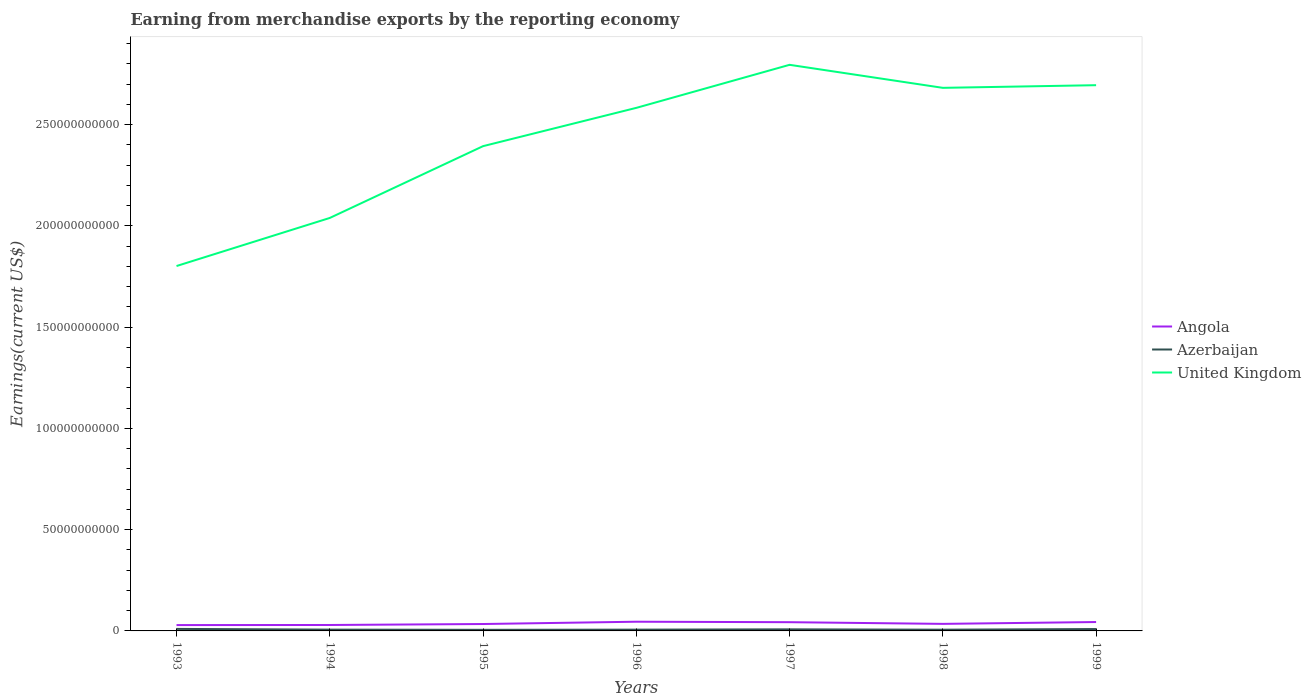Does the line corresponding to Angola intersect with the line corresponding to United Kingdom?
Offer a terse response. No. Is the number of lines equal to the number of legend labels?
Offer a terse response. Yes. Across all years, what is the maximum amount earned from merchandise exports in United Kingdom?
Your response must be concise. 1.80e+11. What is the total amount earned from merchandise exports in Angola in the graph?
Your response must be concise. 2.34e+08. What is the difference between the highest and the second highest amount earned from merchandise exports in Azerbaijan?
Keep it short and to the point. 4.46e+08. What is the difference between the highest and the lowest amount earned from merchandise exports in Angola?
Offer a very short reply. 3. Is the amount earned from merchandise exports in Azerbaijan strictly greater than the amount earned from merchandise exports in United Kingdom over the years?
Give a very brief answer. Yes. How many lines are there?
Your answer should be compact. 3. How many years are there in the graph?
Give a very brief answer. 7. What is the difference between two consecutive major ticks on the Y-axis?
Give a very brief answer. 5.00e+1. Are the values on the major ticks of Y-axis written in scientific E-notation?
Your answer should be compact. No. Does the graph contain any zero values?
Provide a succinct answer. No. How many legend labels are there?
Provide a short and direct response. 3. What is the title of the graph?
Give a very brief answer. Earning from merchandise exports by the reporting economy. Does "Small states" appear as one of the legend labels in the graph?
Give a very brief answer. No. What is the label or title of the Y-axis?
Provide a short and direct response. Earnings(current US$). What is the Earnings(current US$) in Angola in 1993?
Offer a very short reply. 2.88e+09. What is the Earnings(current US$) in Azerbaijan in 1993?
Give a very brief answer. 9.93e+08. What is the Earnings(current US$) in United Kingdom in 1993?
Make the answer very short. 1.80e+11. What is the Earnings(current US$) in Angola in 1994?
Keep it short and to the point. 2.93e+09. What is the Earnings(current US$) in Azerbaijan in 1994?
Your answer should be compact. 6.37e+08. What is the Earnings(current US$) of United Kingdom in 1994?
Offer a terse response. 2.04e+11. What is the Earnings(current US$) in Angola in 1995?
Your answer should be very brief. 3.41e+09. What is the Earnings(current US$) in Azerbaijan in 1995?
Your answer should be very brief. 5.47e+08. What is the Earnings(current US$) in United Kingdom in 1995?
Keep it short and to the point. 2.39e+11. What is the Earnings(current US$) of Angola in 1996?
Offer a very short reply. 4.54e+09. What is the Earnings(current US$) in Azerbaijan in 1996?
Your response must be concise. 6.31e+08. What is the Earnings(current US$) in United Kingdom in 1996?
Provide a short and direct response. 2.58e+11. What is the Earnings(current US$) in Angola in 1997?
Your answer should be compact. 4.31e+09. What is the Earnings(current US$) of Azerbaijan in 1997?
Provide a short and direct response. 7.81e+08. What is the Earnings(current US$) of United Kingdom in 1997?
Your answer should be compact. 2.80e+11. What is the Earnings(current US$) in Angola in 1998?
Offer a very short reply. 3.48e+09. What is the Earnings(current US$) in Azerbaijan in 1998?
Your answer should be very brief. 6.07e+08. What is the Earnings(current US$) of United Kingdom in 1998?
Your answer should be very brief. 2.68e+11. What is the Earnings(current US$) of Angola in 1999?
Provide a succinct answer. 4.39e+09. What is the Earnings(current US$) in Azerbaijan in 1999?
Your response must be concise. 9.29e+08. What is the Earnings(current US$) of United Kingdom in 1999?
Your answer should be compact. 2.69e+11. Across all years, what is the maximum Earnings(current US$) of Angola?
Give a very brief answer. 4.54e+09. Across all years, what is the maximum Earnings(current US$) of Azerbaijan?
Provide a succinct answer. 9.93e+08. Across all years, what is the maximum Earnings(current US$) of United Kingdom?
Your answer should be very brief. 2.80e+11. Across all years, what is the minimum Earnings(current US$) in Angola?
Give a very brief answer. 2.88e+09. Across all years, what is the minimum Earnings(current US$) of Azerbaijan?
Offer a very short reply. 5.47e+08. Across all years, what is the minimum Earnings(current US$) of United Kingdom?
Provide a short and direct response. 1.80e+11. What is the total Earnings(current US$) of Angola in the graph?
Your response must be concise. 2.60e+1. What is the total Earnings(current US$) of Azerbaijan in the graph?
Your answer should be very brief. 5.13e+09. What is the total Earnings(current US$) of United Kingdom in the graph?
Your answer should be compact. 1.70e+12. What is the difference between the Earnings(current US$) in Angola in 1993 and that in 1994?
Provide a short and direct response. -5.01e+07. What is the difference between the Earnings(current US$) in Azerbaijan in 1993 and that in 1994?
Keep it short and to the point. 3.56e+08. What is the difference between the Earnings(current US$) of United Kingdom in 1993 and that in 1994?
Provide a succinct answer. -2.37e+1. What is the difference between the Earnings(current US$) in Angola in 1993 and that in 1995?
Ensure brevity in your answer.  -5.28e+08. What is the difference between the Earnings(current US$) of Azerbaijan in 1993 and that in 1995?
Your response must be concise. 4.46e+08. What is the difference between the Earnings(current US$) of United Kingdom in 1993 and that in 1995?
Provide a short and direct response. -5.92e+1. What is the difference between the Earnings(current US$) in Angola in 1993 and that in 1996?
Make the answer very short. -1.66e+09. What is the difference between the Earnings(current US$) of Azerbaijan in 1993 and that in 1996?
Offer a terse response. 3.62e+08. What is the difference between the Earnings(current US$) in United Kingdom in 1993 and that in 1996?
Give a very brief answer. -7.81e+1. What is the difference between the Earnings(current US$) of Angola in 1993 and that in 1997?
Make the answer very short. -1.43e+09. What is the difference between the Earnings(current US$) in Azerbaijan in 1993 and that in 1997?
Ensure brevity in your answer.  2.12e+08. What is the difference between the Earnings(current US$) of United Kingdom in 1993 and that in 1997?
Your answer should be very brief. -9.94e+1. What is the difference between the Earnings(current US$) in Angola in 1993 and that in 1998?
Offer a very short reply. -5.94e+08. What is the difference between the Earnings(current US$) of Azerbaijan in 1993 and that in 1998?
Your answer should be very brief. 3.86e+08. What is the difference between the Earnings(current US$) in United Kingdom in 1993 and that in 1998?
Your answer should be very brief. -8.80e+1. What is the difference between the Earnings(current US$) in Angola in 1993 and that in 1999?
Make the answer very short. -1.51e+09. What is the difference between the Earnings(current US$) in Azerbaijan in 1993 and that in 1999?
Ensure brevity in your answer.  6.39e+07. What is the difference between the Earnings(current US$) of United Kingdom in 1993 and that in 1999?
Your answer should be very brief. -8.93e+1. What is the difference between the Earnings(current US$) in Angola in 1994 and that in 1995?
Ensure brevity in your answer.  -4.78e+08. What is the difference between the Earnings(current US$) of Azerbaijan in 1994 and that in 1995?
Provide a succinct answer. 9.03e+07. What is the difference between the Earnings(current US$) of United Kingdom in 1994 and that in 1995?
Your answer should be compact. -3.55e+1. What is the difference between the Earnings(current US$) of Angola in 1994 and that in 1996?
Offer a very short reply. -1.61e+09. What is the difference between the Earnings(current US$) in Azerbaijan in 1994 and that in 1996?
Your answer should be very brief. 6.21e+06. What is the difference between the Earnings(current US$) of United Kingdom in 1994 and that in 1996?
Keep it short and to the point. -5.44e+1. What is the difference between the Earnings(current US$) of Angola in 1994 and that in 1997?
Your answer should be compact. -1.38e+09. What is the difference between the Earnings(current US$) in Azerbaijan in 1994 and that in 1997?
Keep it short and to the point. -1.44e+08. What is the difference between the Earnings(current US$) of United Kingdom in 1994 and that in 1997?
Provide a succinct answer. -7.56e+1. What is the difference between the Earnings(current US$) in Angola in 1994 and that in 1998?
Ensure brevity in your answer.  -5.44e+08. What is the difference between the Earnings(current US$) in Azerbaijan in 1994 and that in 1998?
Offer a very short reply. 3.04e+07. What is the difference between the Earnings(current US$) of United Kingdom in 1994 and that in 1998?
Keep it short and to the point. -6.42e+1. What is the difference between the Earnings(current US$) of Angola in 1994 and that in 1999?
Ensure brevity in your answer.  -1.46e+09. What is the difference between the Earnings(current US$) of Azerbaijan in 1994 and that in 1999?
Offer a very short reply. -2.92e+08. What is the difference between the Earnings(current US$) in United Kingdom in 1994 and that in 1999?
Your response must be concise. -6.56e+1. What is the difference between the Earnings(current US$) of Angola in 1995 and that in 1996?
Give a very brief answer. -1.13e+09. What is the difference between the Earnings(current US$) of Azerbaijan in 1995 and that in 1996?
Ensure brevity in your answer.  -8.41e+07. What is the difference between the Earnings(current US$) in United Kingdom in 1995 and that in 1996?
Ensure brevity in your answer.  -1.89e+1. What is the difference between the Earnings(current US$) of Angola in 1995 and that in 1997?
Make the answer very short. -8.99e+08. What is the difference between the Earnings(current US$) in Azerbaijan in 1995 and that in 1997?
Offer a very short reply. -2.34e+08. What is the difference between the Earnings(current US$) of United Kingdom in 1995 and that in 1997?
Your answer should be very brief. -4.02e+1. What is the difference between the Earnings(current US$) in Angola in 1995 and that in 1998?
Offer a terse response. -6.57e+07. What is the difference between the Earnings(current US$) of Azerbaijan in 1995 and that in 1998?
Make the answer very short. -5.99e+07. What is the difference between the Earnings(current US$) in United Kingdom in 1995 and that in 1998?
Make the answer very short. -2.88e+1. What is the difference between the Earnings(current US$) in Angola in 1995 and that in 1999?
Give a very brief answer. -9.82e+08. What is the difference between the Earnings(current US$) in Azerbaijan in 1995 and that in 1999?
Offer a very short reply. -3.82e+08. What is the difference between the Earnings(current US$) of United Kingdom in 1995 and that in 1999?
Offer a terse response. -3.01e+1. What is the difference between the Earnings(current US$) in Angola in 1996 and that in 1997?
Keep it short and to the point. 2.34e+08. What is the difference between the Earnings(current US$) of Azerbaijan in 1996 and that in 1997?
Your answer should be compact. -1.50e+08. What is the difference between the Earnings(current US$) of United Kingdom in 1996 and that in 1997?
Offer a very short reply. -2.13e+1. What is the difference between the Earnings(current US$) of Angola in 1996 and that in 1998?
Make the answer very short. 1.07e+09. What is the difference between the Earnings(current US$) in Azerbaijan in 1996 and that in 1998?
Provide a succinct answer. 2.42e+07. What is the difference between the Earnings(current US$) in United Kingdom in 1996 and that in 1998?
Make the answer very short. -9.88e+09. What is the difference between the Earnings(current US$) of Angola in 1996 and that in 1999?
Keep it short and to the point. 1.50e+08. What is the difference between the Earnings(current US$) of Azerbaijan in 1996 and that in 1999?
Give a very brief answer. -2.98e+08. What is the difference between the Earnings(current US$) of United Kingdom in 1996 and that in 1999?
Offer a terse response. -1.12e+1. What is the difference between the Earnings(current US$) in Angola in 1997 and that in 1998?
Your answer should be very brief. 8.33e+08. What is the difference between the Earnings(current US$) in Azerbaijan in 1997 and that in 1998?
Keep it short and to the point. 1.74e+08. What is the difference between the Earnings(current US$) in United Kingdom in 1997 and that in 1998?
Your answer should be very brief. 1.14e+1. What is the difference between the Earnings(current US$) in Angola in 1997 and that in 1999?
Make the answer very short. -8.33e+07. What is the difference between the Earnings(current US$) in Azerbaijan in 1997 and that in 1999?
Give a very brief answer. -1.48e+08. What is the difference between the Earnings(current US$) in United Kingdom in 1997 and that in 1999?
Make the answer very short. 1.01e+1. What is the difference between the Earnings(current US$) of Angola in 1998 and that in 1999?
Provide a short and direct response. -9.16e+08. What is the difference between the Earnings(current US$) in Azerbaijan in 1998 and that in 1999?
Make the answer very short. -3.22e+08. What is the difference between the Earnings(current US$) in United Kingdom in 1998 and that in 1999?
Offer a very short reply. -1.31e+09. What is the difference between the Earnings(current US$) in Angola in 1993 and the Earnings(current US$) in Azerbaijan in 1994?
Ensure brevity in your answer.  2.25e+09. What is the difference between the Earnings(current US$) in Angola in 1993 and the Earnings(current US$) in United Kingdom in 1994?
Make the answer very short. -2.01e+11. What is the difference between the Earnings(current US$) in Azerbaijan in 1993 and the Earnings(current US$) in United Kingdom in 1994?
Offer a very short reply. -2.03e+11. What is the difference between the Earnings(current US$) in Angola in 1993 and the Earnings(current US$) in Azerbaijan in 1995?
Keep it short and to the point. 2.34e+09. What is the difference between the Earnings(current US$) in Angola in 1993 and the Earnings(current US$) in United Kingdom in 1995?
Provide a succinct answer. -2.37e+11. What is the difference between the Earnings(current US$) in Azerbaijan in 1993 and the Earnings(current US$) in United Kingdom in 1995?
Your response must be concise. -2.38e+11. What is the difference between the Earnings(current US$) of Angola in 1993 and the Earnings(current US$) of Azerbaijan in 1996?
Your response must be concise. 2.25e+09. What is the difference between the Earnings(current US$) of Angola in 1993 and the Earnings(current US$) of United Kingdom in 1996?
Keep it short and to the point. -2.55e+11. What is the difference between the Earnings(current US$) of Azerbaijan in 1993 and the Earnings(current US$) of United Kingdom in 1996?
Ensure brevity in your answer.  -2.57e+11. What is the difference between the Earnings(current US$) of Angola in 1993 and the Earnings(current US$) of Azerbaijan in 1997?
Provide a succinct answer. 2.10e+09. What is the difference between the Earnings(current US$) in Angola in 1993 and the Earnings(current US$) in United Kingdom in 1997?
Give a very brief answer. -2.77e+11. What is the difference between the Earnings(current US$) of Azerbaijan in 1993 and the Earnings(current US$) of United Kingdom in 1997?
Keep it short and to the point. -2.79e+11. What is the difference between the Earnings(current US$) in Angola in 1993 and the Earnings(current US$) in Azerbaijan in 1998?
Make the answer very short. 2.28e+09. What is the difference between the Earnings(current US$) in Angola in 1993 and the Earnings(current US$) in United Kingdom in 1998?
Offer a terse response. -2.65e+11. What is the difference between the Earnings(current US$) in Azerbaijan in 1993 and the Earnings(current US$) in United Kingdom in 1998?
Your answer should be very brief. -2.67e+11. What is the difference between the Earnings(current US$) of Angola in 1993 and the Earnings(current US$) of Azerbaijan in 1999?
Offer a very short reply. 1.95e+09. What is the difference between the Earnings(current US$) in Angola in 1993 and the Earnings(current US$) in United Kingdom in 1999?
Give a very brief answer. -2.67e+11. What is the difference between the Earnings(current US$) of Azerbaijan in 1993 and the Earnings(current US$) of United Kingdom in 1999?
Make the answer very short. -2.69e+11. What is the difference between the Earnings(current US$) in Angola in 1994 and the Earnings(current US$) in Azerbaijan in 1995?
Your response must be concise. 2.39e+09. What is the difference between the Earnings(current US$) in Angola in 1994 and the Earnings(current US$) in United Kingdom in 1995?
Provide a short and direct response. -2.36e+11. What is the difference between the Earnings(current US$) in Azerbaijan in 1994 and the Earnings(current US$) in United Kingdom in 1995?
Keep it short and to the point. -2.39e+11. What is the difference between the Earnings(current US$) of Angola in 1994 and the Earnings(current US$) of Azerbaijan in 1996?
Provide a short and direct response. 2.30e+09. What is the difference between the Earnings(current US$) in Angola in 1994 and the Earnings(current US$) in United Kingdom in 1996?
Provide a succinct answer. -2.55e+11. What is the difference between the Earnings(current US$) in Azerbaijan in 1994 and the Earnings(current US$) in United Kingdom in 1996?
Your response must be concise. -2.58e+11. What is the difference between the Earnings(current US$) in Angola in 1994 and the Earnings(current US$) in Azerbaijan in 1997?
Provide a short and direct response. 2.15e+09. What is the difference between the Earnings(current US$) in Angola in 1994 and the Earnings(current US$) in United Kingdom in 1997?
Offer a terse response. -2.77e+11. What is the difference between the Earnings(current US$) of Azerbaijan in 1994 and the Earnings(current US$) of United Kingdom in 1997?
Keep it short and to the point. -2.79e+11. What is the difference between the Earnings(current US$) of Angola in 1994 and the Earnings(current US$) of Azerbaijan in 1998?
Keep it short and to the point. 2.33e+09. What is the difference between the Earnings(current US$) of Angola in 1994 and the Earnings(current US$) of United Kingdom in 1998?
Keep it short and to the point. -2.65e+11. What is the difference between the Earnings(current US$) in Azerbaijan in 1994 and the Earnings(current US$) in United Kingdom in 1998?
Your response must be concise. -2.68e+11. What is the difference between the Earnings(current US$) in Angola in 1994 and the Earnings(current US$) in Azerbaijan in 1999?
Your answer should be very brief. 2.00e+09. What is the difference between the Earnings(current US$) of Angola in 1994 and the Earnings(current US$) of United Kingdom in 1999?
Your response must be concise. -2.67e+11. What is the difference between the Earnings(current US$) in Azerbaijan in 1994 and the Earnings(current US$) in United Kingdom in 1999?
Keep it short and to the point. -2.69e+11. What is the difference between the Earnings(current US$) in Angola in 1995 and the Earnings(current US$) in Azerbaijan in 1996?
Provide a short and direct response. 2.78e+09. What is the difference between the Earnings(current US$) of Angola in 1995 and the Earnings(current US$) of United Kingdom in 1996?
Your answer should be compact. -2.55e+11. What is the difference between the Earnings(current US$) of Azerbaijan in 1995 and the Earnings(current US$) of United Kingdom in 1996?
Make the answer very short. -2.58e+11. What is the difference between the Earnings(current US$) in Angola in 1995 and the Earnings(current US$) in Azerbaijan in 1997?
Provide a succinct answer. 2.63e+09. What is the difference between the Earnings(current US$) of Angola in 1995 and the Earnings(current US$) of United Kingdom in 1997?
Make the answer very short. -2.76e+11. What is the difference between the Earnings(current US$) of Azerbaijan in 1995 and the Earnings(current US$) of United Kingdom in 1997?
Your response must be concise. -2.79e+11. What is the difference between the Earnings(current US$) in Angola in 1995 and the Earnings(current US$) in Azerbaijan in 1998?
Make the answer very short. 2.80e+09. What is the difference between the Earnings(current US$) in Angola in 1995 and the Earnings(current US$) in United Kingdom in 1998?
Provide a succinct answer. -2.65e+11. What is the difference between the Earnings(current US$) in Azerbaijan in 1995 and the Earnings(current US$) in United Kingdom in 1998?
Ensure brevity in your answer.  -2.68e+11. What is the difference between the Earnings(current US$) in Angola in 1995 and the Earnings(current US$) in Azerbaijan in 1999?
Your answer should be very brief. 2.48e+09. What is the difference between the Earnings(current US$) of Angola in 1995 and the Earnings(current US$) of United Kingdom in 1999?
Ensure brevity in your answer.  -2.66e+11. What is the difference between the Earnings(current US$) in Azerbaijan in 1995 and the Earnings(current US$) in United Kingdom in 1999?
Ensure brevity in your answer.  -2.69e+11. What is the difference between the Earnings(current US$) in Angola in 1996 and the Earnings(current US$) in Azerbaijan in 1997?
Offer a very short reply. 3.76e+09. What is the difference between the Earnings(current US$) in Angola in 1996 and the Earnings(current US$) in United Kingdom in 1997?
Offer a very short reply. -2.75e+11. What is the difference between the Earnings(current US$) in Azerbaijan in 1996 and the Earnings(current US$) in United Kingdom in 1997?
Keep it short and to the point. -2.79e+11. What is the difference between the Earnings(current US$) in Angola in 1996 and the Earnings(current US$) in Azerbaijan in 1998?
Offer a very short reply. 3.94e+09. What is the difference between the Earnings(current US$) of Angola in 1996 and the Earnings(current US$) of United Kingdom in 1998?
Give a very brief answer. -2.64e+11. What is the difference between the Earnings(current US$) in Azerbaijan in 1996 and the Earnings(current US$) in United Kingdom in 1998?
Provide a short and direct response. -2.68e+11. What is the difference between the Earnings(current US$) of Angola in 1996 and the Earnings(current US$) of Azerbaijan in 1999?
Provide a short and direct response. 3.61e+09. What is the difference between the Earnings(current US$) in Angola in 1996 and the Earnings(current US$) in United Kingdom in 1999?
Offer a terse response. -2.65e+11. What is the difference between the Earnings(current US$) of Azerbaijan in 1996 and the Earnings(current US$) of United Kingdom in 1999?
Your answer should be compact. -2.69e+11. What is the difference between the Earnings(current US$) in Angola in 1997 and the Earnings(current US$) in Azerbaijan in 1998?
Your answer should be compact. 3.70e+09. What is the difference between the Earnings(current US$) in Angola in 1997 and the Earnings(current US$) in United Kingdom in 1998?
Keep it short and to the point. -2.64e+11. What is the difference between the Earnings(current US$) of Azerbaijan in 1997 and the Earnings(current US$) of United Kingdom in 1998?
Offer a terse response. -2.67e+11. What is the difference between the Earnings(current US$) in Angola in 1997 and the Earnings(current US$) in Azerbaijan in 1999?
Offer a terse response. 3.38e+09. What is the difference between the Earnings(current US$) in Angola in 1997 and the Earnings(current US$) in United Kingdom in 1999?
Your response must be concise. -2.65e+11. What is the difference between the Earnings(current US$) of Azerbaijan in 1997 and the Earnings(current US$) of United Kingdom in 1999?
Make the answer very short. -2.69e+11. What is the difference between the Earnings(current US$) in Angola in 1998 and the Earnings(current US$) in Azerbaijan in 1999?
Offer a terse response. 2.55e+09. What is the difference between the Earnings(current US$) in Angola in 1998 and the Earnings(current US$) in United Kingdom in 1999?
Provide a succinct answer. -2.66e+11. What is the difference between the Earnings(current US$) of Azerbaijan in 1998 and the Earnings(current US$) of United Kingdom in 1999?
Your answer should be very brief. -2.69e+11. What is the average Earnings(current US$) in Angola per year?
Your answer should be very brief. 3.71e+09. What is the average Earnings(current US$) in Azerbaijan per year?
Ensure brevity in your answer.  7.32e+08. What is the average Earnings(current US$) of United Kingdom per year?
Provide a succinct answer. 2.43e+11. In the year 1993, what is the difference between the Earnings(current US$) in Angola and Earnings(current US$) in Azerbaijan?
Provide a succinct answer. 1.89e+09. In the year 1993, what is the difference between the Earnings(current US$) in Angola and Earnings(current US$) in United Kingdom?
Your response must be concise. -1.77e+11. In the year 1993, what is the difference between the Earnings(current US$) of Azerbaijan and Earnings(current US$) of United Kingdom?
Give a very brief answer. -1.79e+11. In the year 1994, what is the difference between the Earnings(current US$) of Angola and Earnings(current US$) of Azerbaijan?
Your response must be concise. 2.30e+09. In the year 1994, what is the difference between the Earnings(current US$) in Angola and Earnings(current US$) in United Kingdom?
Your response must be concise. -2.01e+11. In the year 1994, what is the difference between the Earnings(current US$) in Azerbaijan and Earnings(current US$) in United Kingdom?
Your answer should be very brief. -2.03e+11. In the year 1995, what is the difference between the Earnings(current US$) in Angola and Earnings(current US$) in Azerbaijan?
Your answer should be compact. 2.86e+09. In the year 1995, what is the difference between the Earnings(current US$) in Angola and Earnings(current US$) in United Kingdom?
Provide a succinct answer. -2.36e+11. In the year 1995, what is the difference between the Earnings(current US$) in Azerbaijan and Earnings(current US$) in United Kingdom?
Provide a succinct answer. -2.39e+11. In the year 1996, what is the difference between the Earnings(current US$) in Angola and Earnings(current US$) in Azerbaijan?
Your answer should be very brief. 3.91e+09. In the year 1996, what is the difference between the Earnings(current US$) of Angola and Earnings(current US$) of United Kingdom?
Offer a terse response. -2.54e+11. In the year 1996, what is the difference between the Earnings(current US$) of Azerbaijan and Earnings(current US$) of United Kingdom?
Provide a short and direct response. -2.58e+11. In the year 1997, what is the difference between the Earnings(current US$) in Angola and Earnings(current US$) in Azerbaijan?
Your answer should be very brief. 3.53e+09. In the year 1997, what is the difference between the Earnings(current US$) of Angola and Earnings(current US$) of United Kingdom?
Your answer should be very brief. -2.75e+11. In the year 1997, what is the difference between the Earnings(current US$) of Azerbaijan and Earnings(current US$) of United Kingdom?
Provide a succinct answer. -2.79e+11. In the year 1998, what is the difference between the Earnings(current US$) of Angola and Earnings(current US$) of Azerbaijan?
Your answer should be very brief. 2.87e+09. In the year 1998, what is the difference between the Earnings(current US$) in Angola and Earnings(current US$) in United Kingdom?
Provide a short and direct response. -2.65e+11. In the year 1998, what is the difference between the Earnings(current US$) of Azerbaijan and Earnings(current US$) of United Kingdom?
Offer a terse response. -2.68e+11. In the year 1999, what is the difference between the Earnings(current US$) in Angola and Earnings(current US$) in Azerbaijan?
Ensure brevity in your answer.  3.46e+09. In the year 1999, what is the difference between the Earnings(current US$) of Angola and Earnings(current US$) of United Kingdom?
Your response must be concise. -2.65e+11. In the year 1999, what is the difference between the Earnings(current US$) in Azerbaijan and Earnings(current US$) in United Kingdom?
Offer a very short reply. -2.69e+11. What is the ratio of the Earnings(current US$) in Angola in 1993 to that in 1994?
Provide a succinct answer. 0.98. What is the ratio of the Earnings(current US$) of Azerbaijan in 1993 to that in 1994?
Provide a succinct answer. 1.56. What is the ratio of the Earnings(current US$) in United Kingdom in 1993 to that in 1994?
Keep it short and to the point. 0.88. What is the ratio of the Earnings(current US$) in Angola in 1993 to that in 1995?
Keep it short and to the point. 0.85. What is the ratio of the Earnings(current US$) of Azerbaijan in 1993 to that in 1995?
Give a very brief answer. 1.82. What is the ratio of the Earnings(current US$) in United Kingdom in 1993 to that in 1995?
Keep it short and to the point. 0.75. What is the ratio of the Earnings(current US$) in Angola in 1993 to that in 1996?
Ensure brevity in your answer.  0.63. What is the ratio of the Earnings(current US$) of Azerbaijan in 1993 to that in 1996?
Offer a very short reply. 1.57. What is the ratio of the Earnings(current US$) of United Kingdom in 1993 to that in 1996?
Give a very brief answer. 0.7. What is the ratio of the Earnings(current US$) in Angola in 1993 to that in 1997?
Your response must be concise. 0.67. What is the ratio of the Earnings(current US$) in Azerbaijan in 1993 to that in 1997?
Your answer should be very brief. 1.27. What is the ratio of the Earnings(current US$) of United Kingdom in 1993 to that in 1997?
Offer a very short reply. 0.64. What is the ratio of the Earnings(current US$) in Angola in 1993 to that in 1998?
Ensure brevity in your answer.  0.83. What is the ratio of the Earnings(current US$) of Azerbaijan in 1993 to that in 1998?
Give a very brief answer. 1.64. What is the ratio of the Earnings(current US$) of United Kingdom in 1993 to that in 1998?
Provide a short and direct response. 0.67. What is the ratio of the Earnings(current US$) in Angola in 1993 to that in 1999?
Keep it short and to the point. 0.66. What is the ratio of the Earnings(current US$) of Azerbaijan in 1993 to that in 1999?
Provide a succinct answer. 1.07. What is the ratio of the Earnings(current US$) in United Kingdom in 1993 to that in 1999?
Keep it short and to the point. 0.67. What is the ratio of the Earnings(current US$) in Angola in 1994 to that in 1995?
Your answer should be very brief. 0.86. What is the ratio of the Earnings(current US$) in Azerbaijan in 1994 to that in 1995?
Offer a very short reply. 1.17. What is the ratio of the Earnings(current US$) of United Kingdom in 1994 to that in 1995?
Your answer should be compact. 0.85. What is the ratio of the Earnings(current US$) of Angola in 1994 to that in 1996?
Give a very brief answer. 0.65. What is the ratio of the Earnings(current US$) of Azerbaijan in 1994 to that in 1996?
Your response must be concise. 1.01. What is the ratio of the Earnings(current US$) of United Kingdom in 1994 to that in 1996?
Keep it short and to the point. 0.79. What is the ratio of the Earnings(current US$) in Angola in 1994 to that in 1997?
Your answer should be very brief. 0.68. What is the ratio of the Earnings(current US$) of Azerbaijan in 1994 to that in 1997?
Offer a very short reply. 0.82. What is the ratio of the Earnings(current US$) in United Kingdom in 1994 to that in 1997?
Offer a terse response. 0.73. What is the ratio of the Earnings(current US$) in Angola in 1994 to that in 1998?
Make the answer very short. 0.84. What is the ratio of the Earnings(current US$) in Azerbaijan in 1994 to that in 1998?
Provide a short and direct response. 1.05. What is the ratio of the Earnings(current US$) of United Kingdom in 1994 to that in 1998?
Give a very brief answer. 0.76. What is the ratio of the Earnings(current US$) in Angola in 1994 to that in 1999?
Offer a terse response. 0.67. What is the ratio of the Earnings(current US$) of Azerbaijan in 1994 to that in 1999?
Provide a succinct answer. 0.69. What is the ratio of the Earnings(current US$) of United Kingdom in 1994 to that in 1999?
Keep it short and to the point. 0.76. What is the ratio of the Earnings(current US$) in Angola in 1995 to that in 1996?
Make the answer very short. 0.75. What is the ratio of the Earnings(current US$) of Azerbaijan in 1995 to that in 1996?
Your answer should be very brief. 0.87. What is the ratio of the Earnings(current US$) in United Kingdom in 1995 to that in 1996?
Keep it short and to the point. 0.93. What is the ratio of the Earnings(current US$) of Angola in 1995 to that in 1997?
Provide a short and direct response. 0.79. What is the ratio of the Earnings(current US$) in Azerbaijan in 1995 to that in 1997?
Your answer should be compact. 0.7. What is the ratio of the Earnings(current US$) in United Kingdom in 1995 to that in 1997?
Your answer should be compact. 0.86. What is the ratio of the Earnings(current US$) of Angola in 1995 to that in 1998?
Provide a succinct answer. 0.98. What is the ratio of the Earnings(current US$) of Azerbaijan in 1995 to that in 1998?
Ensure brevity in your answer.  0.9. What is the ratio of the Earnings(current US$) of United Kingdom in 1995 to that in 1998?
Give a very brief answer. 0.89. What is the ratio of the Earnings(current US$) in Angola in 1995 to that in 1999?
Offer a very short reply. 0.78. What is the ratio of the Earnings(current US$) in Azerbaijan in 1995 to that in 1999?
Make the answer very short. 0.59. What is the ratio of the Earnings(current US$) of United Kingdom in 1995 to that in 1999?
Make the answer very short. 0.89. What is the ratio of the Earnings(current US$) in Angola in 1996 to that in 1997?
Offer a terse response. 1.05. What is the ratio of the Earnings(current US$) in Azerbaijan in 1996 to that in 1997?
Make the answer very short. 0.81. What is the ratio of the Earnings(current US$) of United Kingdom in 1996 to that in 1997?
Offer a terse response. 0.92. What is the ratio of the Earnings(current US$) in Angola in 1996 to that in 1998?
Your answer should be compact. 1.31. What is the ratio of the Earnings(current US$) in Azerbaijan in 1996 to that in 1998?
Your answer should be compact. 1.04. What is the ratio of the Earnings(current US$) of United Kingdom in 1996 to that in 1998?
Offer a terse response. 0.96. What is the ratio of the Earnings(current US$) in Angola in 1996 to that in 1999?
Provide a succinct answer. 1.03. What is the ratio of the Earnings(current US$) in Azerbaijan in 1996 to that in 1999?
Ensure brevity in your answer.  0.68. What is the ratio of the Earnings(current US$) of United Kingdom in 1996 to that in 1999?
Offer a very short reply. 0.96. What is the ratio of the Earnings(current US$) in Angola in 1997 to that in 1998?
Provide a short and direct response. 1.24. What is the ratio of the Earnings(current US$) of Azerbaijan in 1997 to that in 1998?
Make the answer very short. 1.29. What is the ratio of the Earnings(current US$) in United Kingdom in 1997 to that in 1998?
Keep it short and to the point. 1.04. What is the ratio of the Earnings(current US$) in Azerbaijan in 1997 to that in 1999?
Provide a succinct answer. 0.84. What is the ratio of the Earnings(current US$) in United Kingdom in 1997 to that in 1999?
Keep it short and to the point. 1.04. What is the ratio of the Earnings(current US$) of Angola in 1998 to that in 1999?
Your response must be concise. 0.79. What is the ratio of the Earnings(current US$) of Azerbaijan in 1998 to that in 1999?
Keep it short and to the point. 0.65. What is the ratio of the Earnings(current US$) of United Kingdom in 1998 to that in 1999?
Offer a terse response. 1. What is the difference between the highest and the second highest Earnings(current US$) of Angola?
Your answer should be very brief. 1.50e+08. What is the difference between the highest and the second highest Earnings(current US$) in Azerbaijan?
Your response must be concise. 6.39e+07. What is the difference between the highest and the second highest Earnings(current US$) of United Kingdom?
Ensure brevity in your answer.  1.01e+1. What is the difference between the highest and the lowest Earnings(current US$) of Angola?
Your response must be concise. 1.66e+09. What is the difference between the highest and the lowest Earnings(current US$) in Azerbaijan?
Your answer should be compact. 4.46e+08. What is the difference between the highest and the lowest Earnings(current US$) in United Kingdom?
Ensure brevity in your answer.  9.94e+1. 